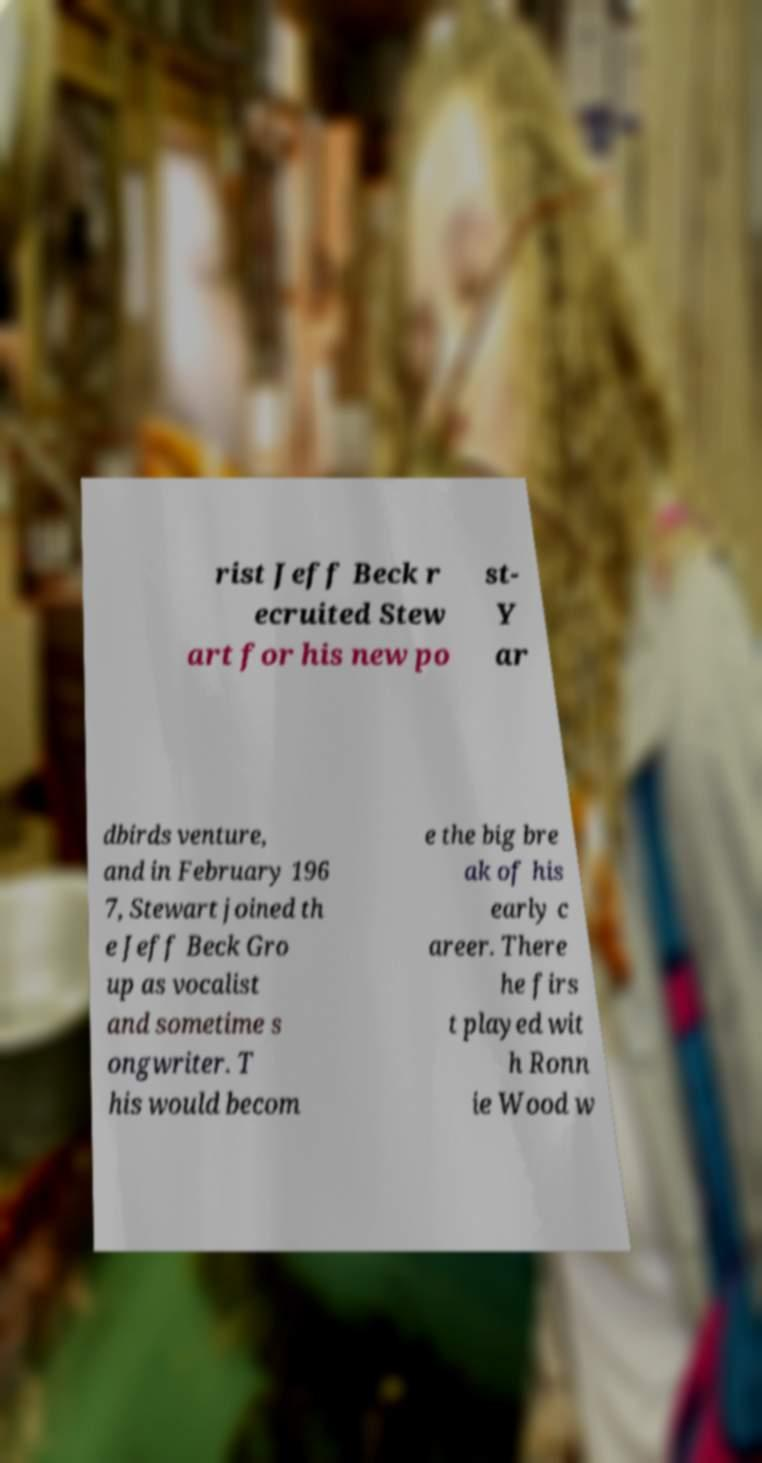Could you extract and type out the text from this image? rist Jeff Beck r ecruited Stew art for his new po st- Y ar dbirds venture, and in February 196 7, Stewart joined th e Jeff Beck Gro up as vocalist and sometime s ongwriter. T his would becom e the big bre ak of his early c areer. There he firs t played wit h Ronn ie Wood w 